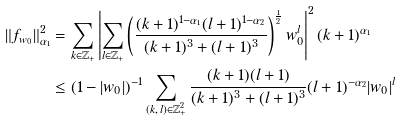Convert formula to latex. <formula><loc_0><loc_0><loc_500><loc_500>\| f _ { w _ { 0 } } \| ^ { 2 } _ { \alpha _ { 1 } } & = \sum _ { k \in \mathbb { Z } _ { + } } \left | \sum _ { l \in \mathbb { Z } _ { + } } \left ( \frac { ( k + 1 ) ^ { 1 - \alpha _ { 1 } } ( l + 1 ) ^ { 1 - \alpha _ { 2 } } } { ( k + 1 ) ^ { 3 } + ( l + 1 ) ^ { 3 } } \right ) ^ { \frac { 1 } { 2 } } w _ { 0 } ^ { l } \right | ^ { 2 } ( k + 1 ) ^ { \alpha _ { 1 } } \\ & \leq ( 1 - | w _ { 0 } | ) ^ { - 1 } \sum _ { ( k , \, l ) \in \mathbb { Z } ^ { 2 } _ { + } } \frac { ( k + 1 ) ( l + 1 ) } { ( k + 1 ) ^ { 3 } + ( l + 1 ) ^ { 3 } } ( l + 1 ) ^ { - \alpha _ { 2 } } | w _ { 0 } | ^ { l }</formula> 